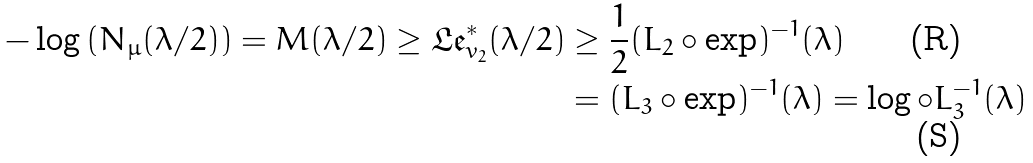Convert formula to latex. <formula><loc_0><loc_0><loc_500><loc_500>- \log \left ( N _ { \mu } ( \lambda / 2 ) \right ) = M ( \lambda / 2 ) \geq \mathfrak { L e } ^ { \ast } _ { v _ { 2 } } ( \lambda / 2 ) & \geq \frac { 1 } { 2 } ( L _ { 2 } \circ \exp ) ^ { - 1 } ( \lambda ) \\ & = ( L _ { 3 } \circ \exp ) ^ { - 1 } ( \lambda ) = \log \circ L _ { 3 } ^ { - 1 } ( \lambda )</formula> 